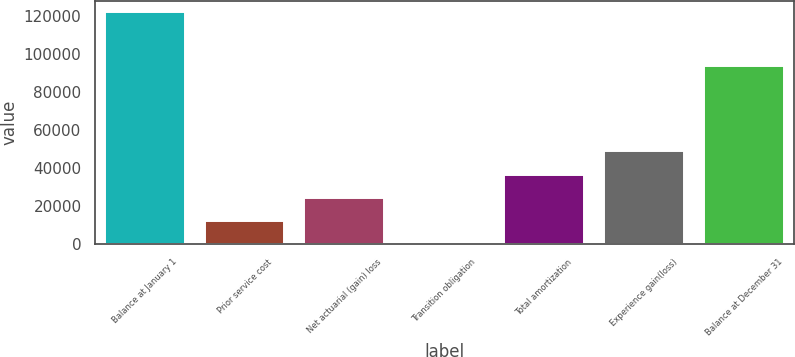Convert chart to OTSL. <chart><loc_0><loc_0><loc_500><loc_500><bar_chart><fcel>Balance at January 1<fcel>Prior service cost<fcel>Net actuarial (gain) loss<fcel>Transition obligation<fcel>Total amortization<fcel>Experience gain(loss)<fcel>Balance at December 31<nl><fcel>121704<fcel>12176.7<fcel>24346.4<fcel>7<fcel>36516.1<fcel>48685.8<fcel>93674<nl></chart> 